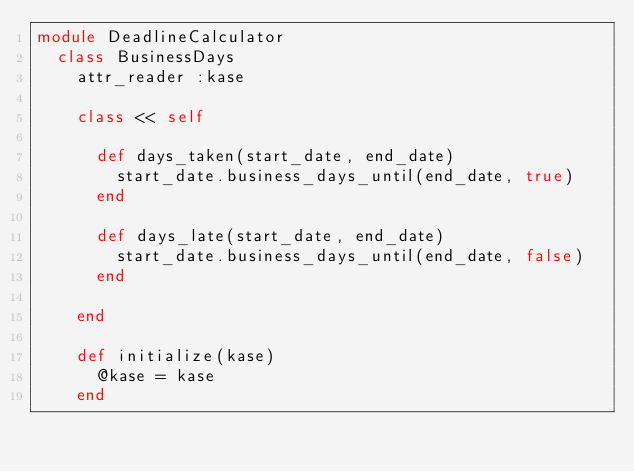Convert code to text. <code><loc_0><loc_0><loc_500><loc_500><_Ruby_>module DeadlineCalculator
  class BusinessDays
    attr_reader :kase

    class << self

      def days_taken(start_date, end_date)
        start_date.business_days_until(end_date, true) 
      end 
  
      def days_late(start_date, end_date)
        start_date.business_days_until(end_date, false) 
      end 

    end 

    def initialize(kase)
      @kase = kase
    end
</code> 